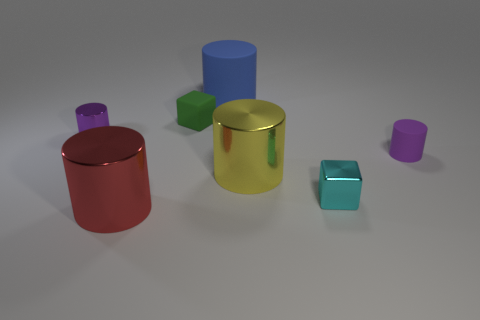Subtract 1 cylinders. How many cylinders are left? 4 Subtract all red cylinders. Subtract all purple blocks. How many cylinders are left? 4 Add 3 big green metal balls. How many objects exist? 10 Subtract all cylinders. How many objects are left? 2 Add 1 small cyan objects. How many small cyan objects are left? 2 Add 4 large blue rubber things. How many large blue rubber things exist? 5 Subtract 0 brown balls. How many objects are left? 7 Subtract all red metal cylinders. Subtract all purple things. How many objects are left? 4 